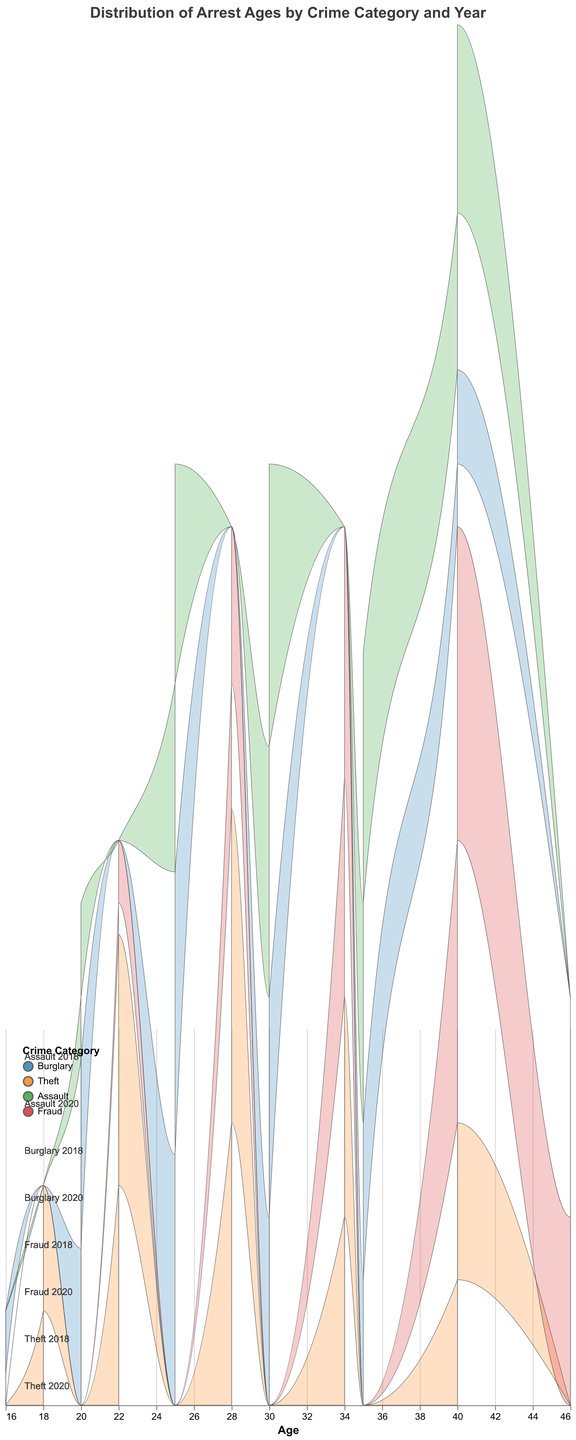What is the title of the plot? The title of the plot is displayed at the top. It reads, "Distribution of Arrest Ages by Crime Category and Year".
Answer: Distribution of Arrest Ages by Crime Category and Year Which crime category shows the highest density for the 2020 year and what is the corresponding age? To find the highest density for 2020, look at the peak of the ridgeline for each crime category for the year 2020. For Fraud, the peak in 2020 is 0.10 at age 40, which is the highest density.
Answer: Fraud, age 40 How does the density of Theft arrests in 2020 compare to that in 2018 for the age 28? Look at the density values for Theft at age 28 for both years. In 2018, the density is 0.09, and in 2020, it is 0.10. The density increased from 2018 to 2020.
Answer: Increased What age group has the highest density for Burglary arrests in 2018? For Burglary in 2018, find the maximum density value. The highest density (0.08) occurs at age 25.
Answer: Age 25 Compare the density values for Assault in the years 2018 and 2020 at age 30. Check the density values at age 30 for Assault in both years. In 2018, the density is 0.08. In 2020, it is 0.09. The density increased from 2018 to 2020 at age 30.
Answer: Increased Which crime category has the most significant increase in density from 2018 to 2020 for any age group? Compare the density changes from 2018 to 2020 for each crime category. For Fraud at age 40, the density increases from 0.09 in 2018 to 0.10 in 2020, which is a noticeable increase.
Answer: Fraud What is the range of ages considered for Fraud arrests in the year 2020? For Fraud in 2020, look at the ages listed. The ages range from 22 to 46 years old.
Answer: 22 to 46 How does the density distribution for Theft in 2018 look in comparison to 2020 for the young age group (18-22)? Check the densities for Theft at ages 18 and 22 for both years. In 2018, the densities are 0.03 at age 18 and 0.07 at age 22. In 2020, these densities are 0.04 at age 18 and 0.08 at age 22. This shows an increase in both cases, indicating a higher density for the young age group in 2020.
Answer: Higher in 2020 Which crime category and year have the lowest density for age 40? Examine the densities at age 40 across all crime categories and years. For Burglary in 2018, the density at age 40 is 0.02, which is the lowest.
Answer: Burglary 2018 